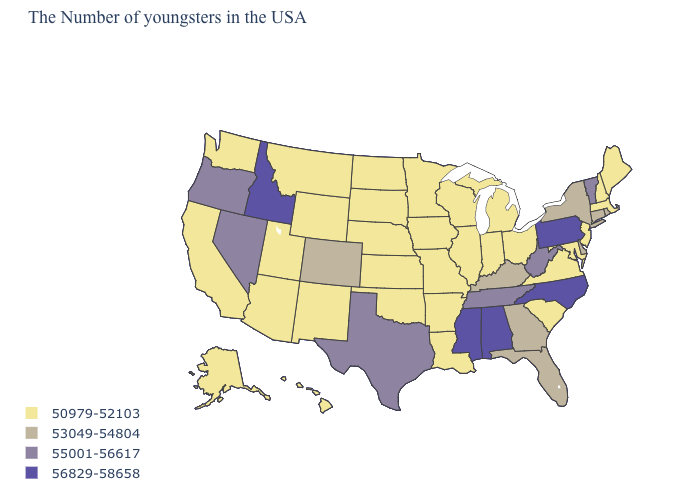What is the value of Alabama?
Short answer required. 56829-58658. How many symbols are there in the legend?
Concise answer only. 4. What is the value of Washington?
Keep it brief. 50979-52103. Which states have the lowest value in the MidWest?
Keep it brief. Ohio, Michigan, Indiana, Wisconsin, Illinois, Missouri, Minnesota, Iowa, Kansas, Nebraska, South Dakota, North Dakota. Among the states that border Ohio , which have the highest value?
Be succinct. Pennsylvania. Does New Mexico have the lowest value in the West?
Write a very short answer. Yes. How many symbols are there in the legend?
Answer briefly. 4. What is the value of South Carolina?
Concise answer only. 50979-52103. What is the value of North Carolina?
Answer briefly. 56829-58658. Does Connecticut have a higher value than West Virginia?
Keep it brief. No. Does Wyoming have the lowest value in the West?
Concise answer only. Yes. What is the value of New York?
Short answer required. 53049-54804. Among the states that border Maine , which have the lowest value?
Give a very brief answer. New Hampshire. Which states have the lowest value in the USA?
Give a very brief answer. Maine, Massachusetts, New Hampshire, New Jersey, Maryland, Virginia, South Carolina, Ohio, Michigan, Indiana, Wisconsin, Illinois, Louisiana, Missouri, Arkansas, Minnesota, Iowa, Kansas, Nebraska, Oklahoma, South Dakota, North Dakota, Wyoming, New Mexico, Utah, Montana, Arizona, California, Washington, Alaska, Hawaii. What is the value of Montana?
Be succinct. 50979-52103. 